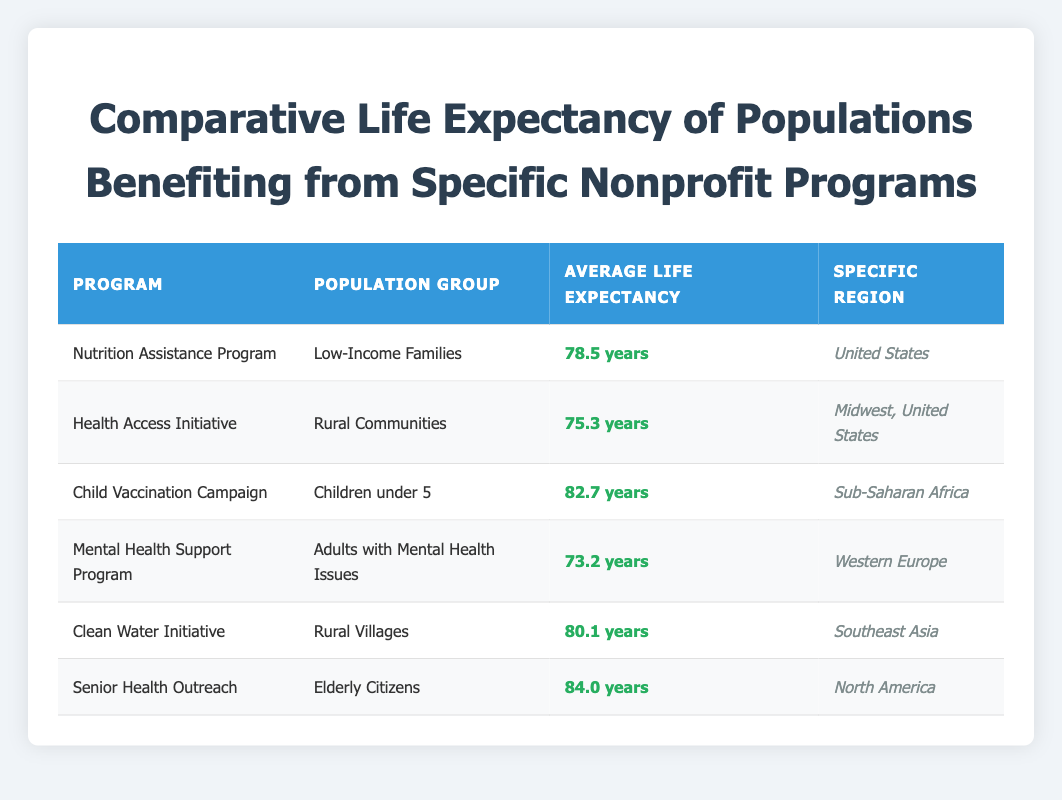What's the average life expectancy for populations benefiting from the Child Vaccination Campaign? Referring to the table, the average life expectancy for the Child Vaccination Campaign is listed as 82.7 years for children under 5 in Sub-Saharan Africa.
Answer: 82.7 years Which program has the lowest average life expectancy, and what is that value? By examining the table, the program with the lowest average life expectancy is the Mental Health Support Program with an average life expectancy of 73.2 years for adults with mental health issues in Western Europe.
Answer: Mental Health Support Program, 73.2 years What is the difference in average life expectancy between populations benefiting from the Clean Water Initiative and the Health Access Initiative? The average life expectancy for the Clean Water Initiative is 80.1 years, while for the Health Access Initiative it is 75.3 years. The difference is calculated as 80.1 - 75.3 = 4.8 years.
Answer: 4.8 years Is the statement "The Nutrition Assistance Program has a higher average life expectancy than the Mental Health Support Program" true? The average life expectancy for the Nutrition Assistance Program is 78.5 years, while for the Mental Health Support Program it is 73.2 years. Since 78.5 is greater than 73.2, the statement is true.
Answer: Yes Among the listed population groups, which group has the highest average life expectancy, and what is that value? According to the table, the group with the highest average life expectancy is the Elderly Citizens benefiting from the Senior Health Outreach program, with an average life expectancy of 84.0 years.
Answer: Elderly Citizens, 84.0 years 